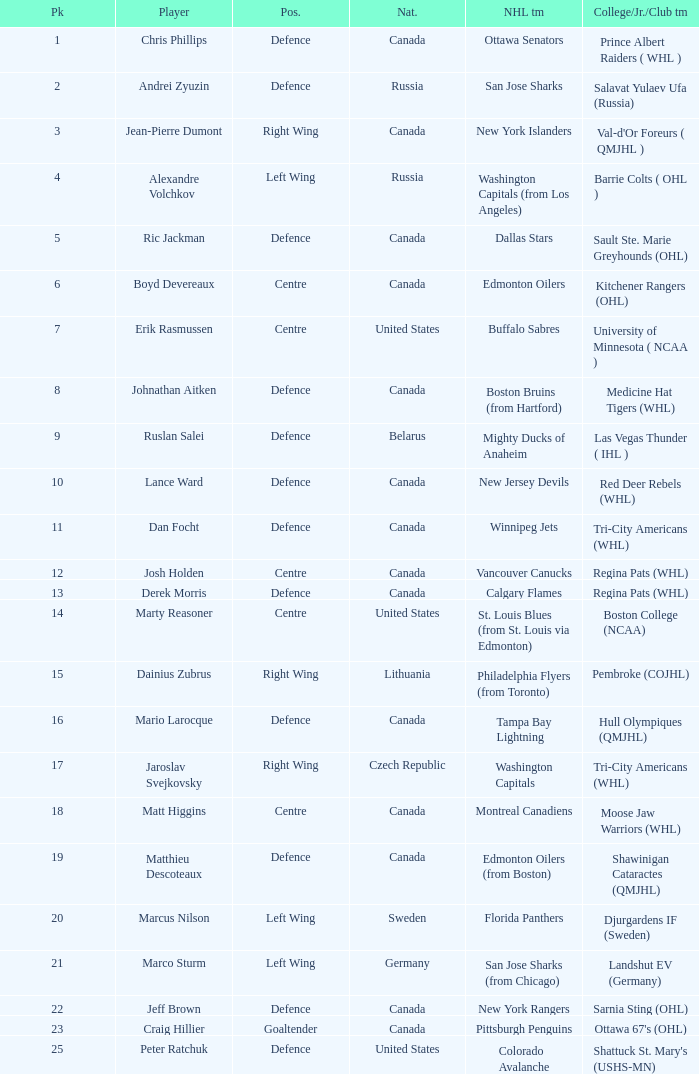What draft pick number was Ric Jackman? 5.0. 